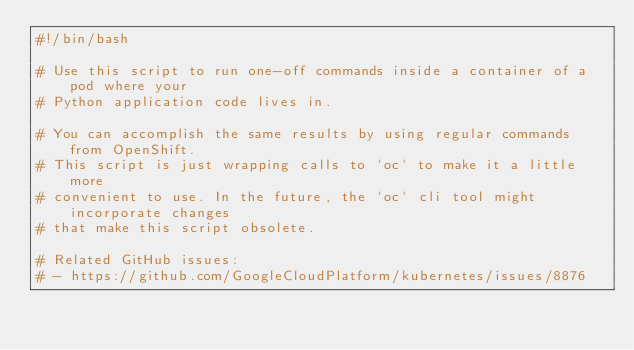<code> <loc_0><loc_0><loc_500><loc_500><_Bash_>#!/bin/bash

# Use this script to run one-off commands inside a container of a pod where your
# Python application code lives in.

# You can accomplish the same results by using regular commands from OpenShift.
# This script is just wrapping calls to `oc` to make it a little more
# convenient to use. In the future, the `oc` cli tool might incorporate changes
# that make this script obsolete.

# Related GitHub issues:
# - https://github.com/GoogleCloudPlatform/kubernetes/issues/8876</code> 